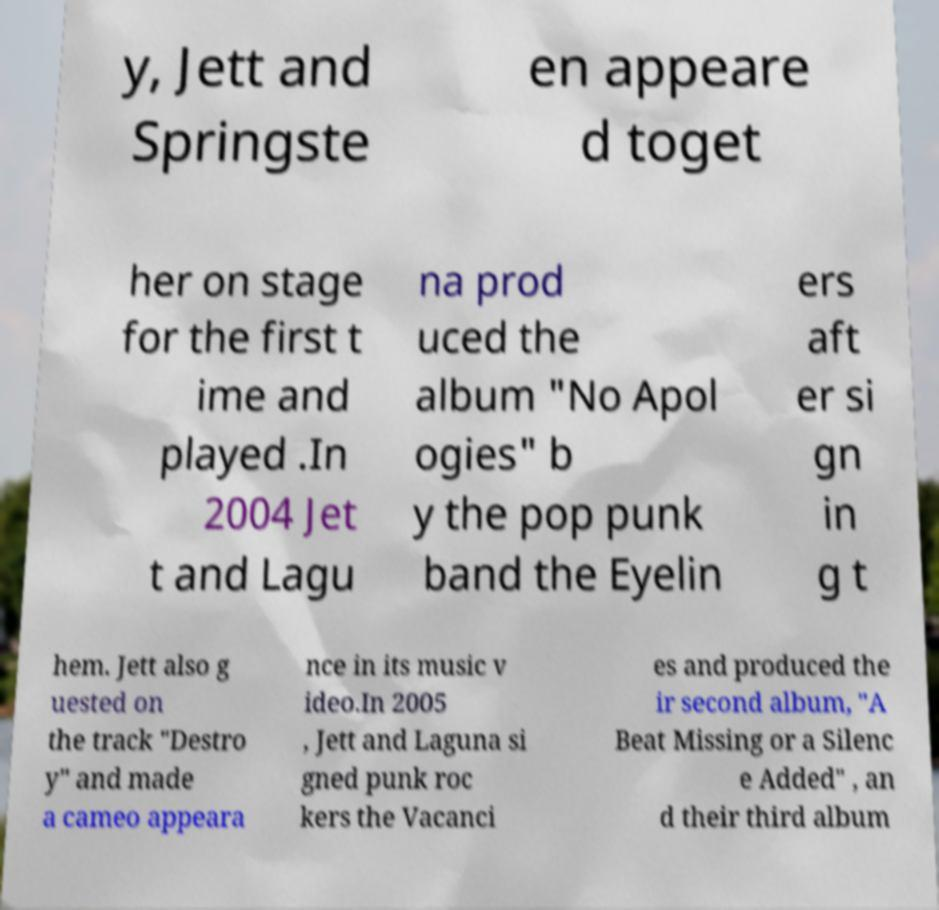Please identify and transcribe the text found in this image. y, Jett and Springste en appeare d toget her on stage for the first t ime and played .In 2004 Jet t and Lagu na prod uced the album "No Apol ogies" b y the pop punk band the Eyelin ers aft er si gn in g t hem. Jett also g uested on the track "Destro y" and made a cameo appeara nce in its music v ideo.In 2005 , Jett and Laguna si gned punk roc kers the Vacanci es and produced the ir second album, "A Beat Missing or a Silenc e Added" , an d their third album 